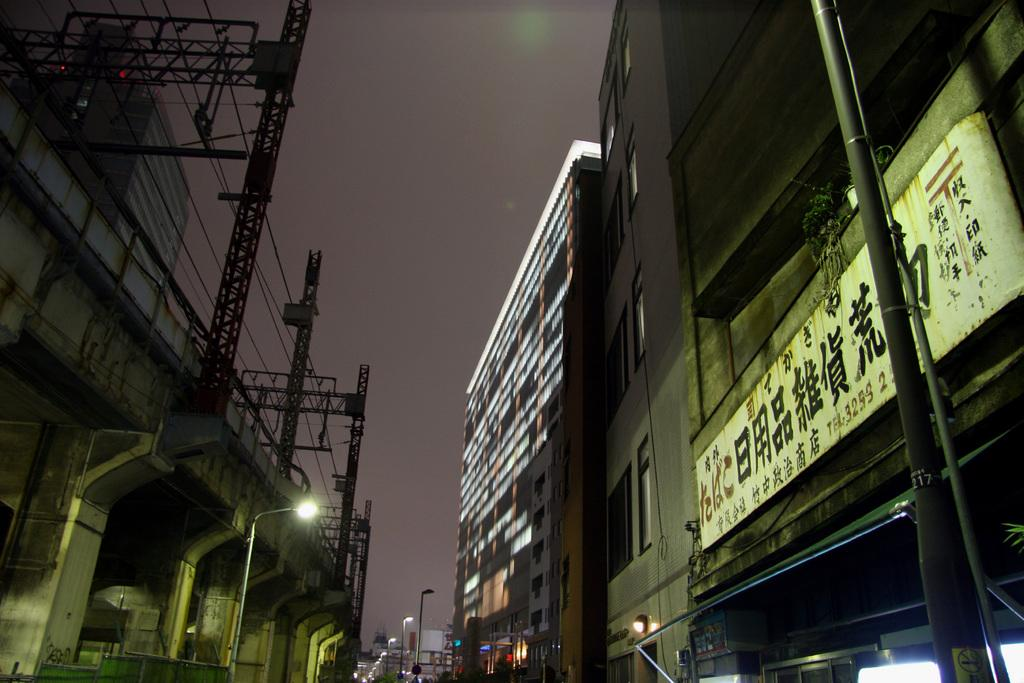What can be seen in the background of the image? There is sky visible in the image. What type of structures are present in the image? There are buildings in the image. What are the poles used for in the image? The poles are likely used for supporting lights or other objects in the image. What is hanging from the poles in the image? Lights are visible in the image. What type of decorations are present in the image? Banners are present in the image. Can you describe any other objects in the image? There are other objects in the image, but their specific details are not mentioned in the provided facts. What type of wire is being used to develop the yard in the image? There is no mention of wire, development, or a yard in the image. The image primarily features buildings, poles, lights, and banners. 